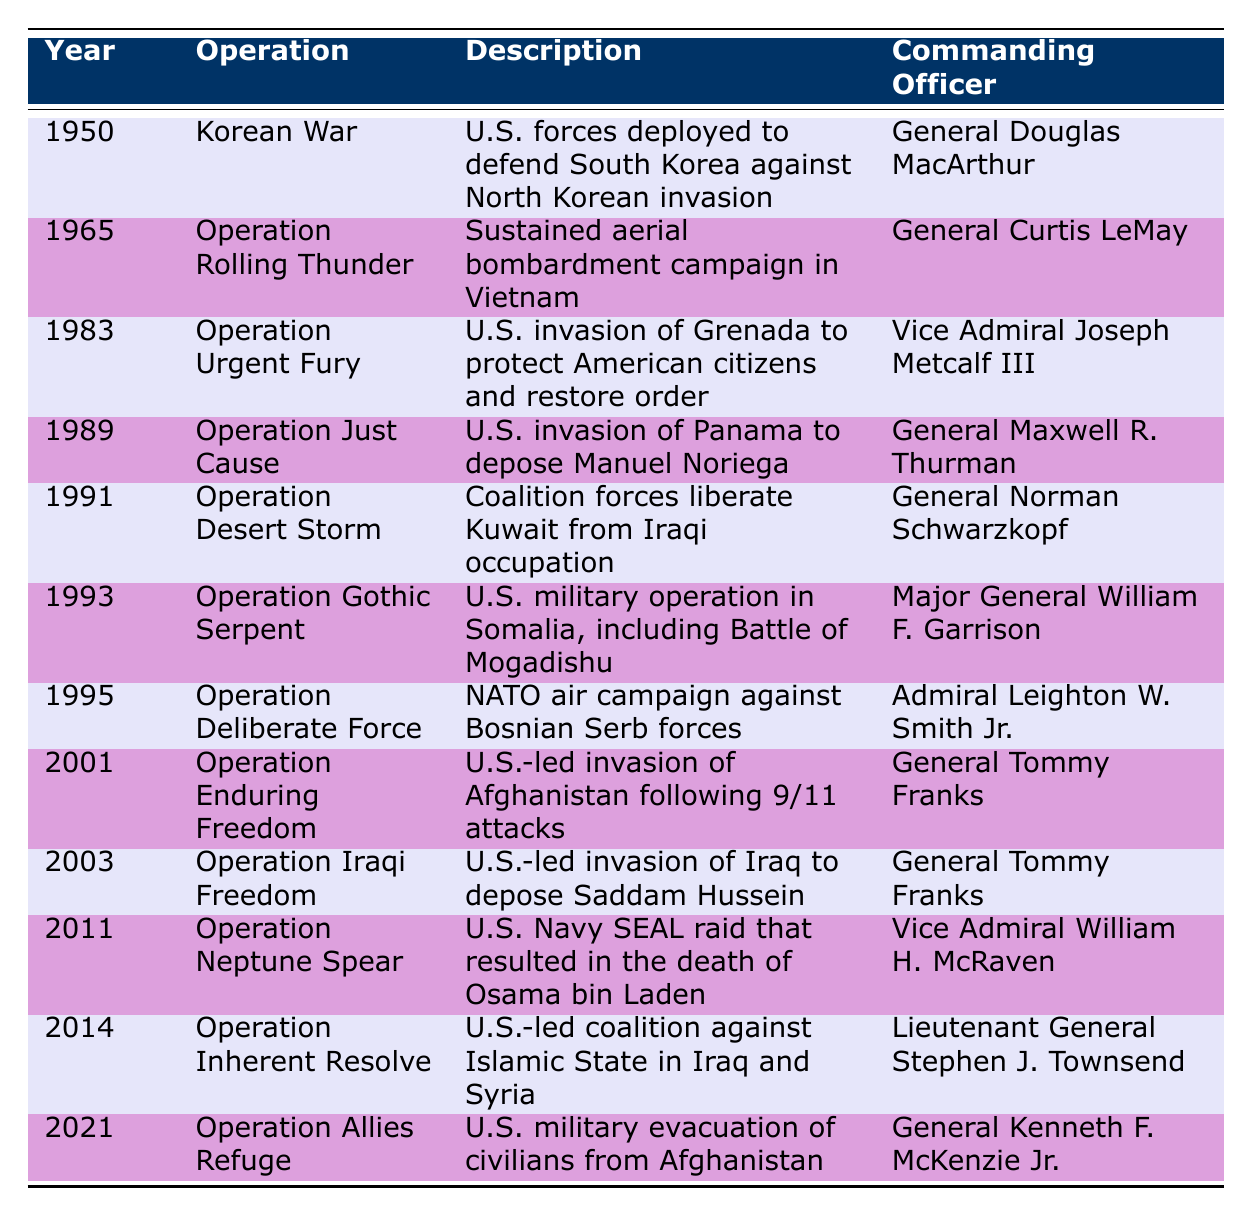What military operation occurred in 1989? The table lists the operations by year. By checking the row for 1989, we see that the operation was "Operation Just Cause."
Answer: Operation Just Cause Who was the commanding officer during Operation Desert Storm? Referring to the row for Operation Desert Storm, which occurred in 1991, the commanding officer listed is General Norman Schwarzkopf.
Answer: General Norman Schwarzkopf How many operations were conducted in the 2000s? To find the number of operations, we can look at the years from 2000 to 2009 in the table, which are 2001 (Operation Enduring Freedom), 2003 (Operation Iraqi Freedom), and we count a total of 2 operations listed in this range.
Answer: 2 Was Operation Urgent Fury conducted after the Korean War? Looking at the years, Operation Urgent Fury occurred in 1983, while the Korean War was in 1950. Since 1983 is after 1950, the statement is true.
Answer: Yes Which operation involved the U.S. Navy SEALs? By scanning the table for military operations involving Navy SEALs, we find that Operation Neptune Spear in 2011 is the one associated with the U.S. Navy SEAL raid.
Answer: Operation Neptune Spear What was the common commanding officer for operations in Afghanistan? Checking the table, we see that both Operation Enduring Freedom (2001) and Operation Allies Refuge (2021) had General Tommy Franks and General Kenneth F. McKenzie Jr. respectively. However, General Tommy Franks is the one who commanded operations in 2001.
Answer: General Tommy Franks What operations took place in the same decade as the Operation Rolling Thunder? Looking at the year 1965 for Operation Rolling Thunder, we can see that the decade included operations in 1965 only, so no other operations were listed within that decade.
Answer: Operation Rolling Thunder Which operation is associated with the death of Osama bin Laden? By referring to the table rows, we can identify that Operation Neptune Spear in 2011 is the military operation that resulted in the death of Osama bin Laden.
Answer: Operation Neptune Spear 